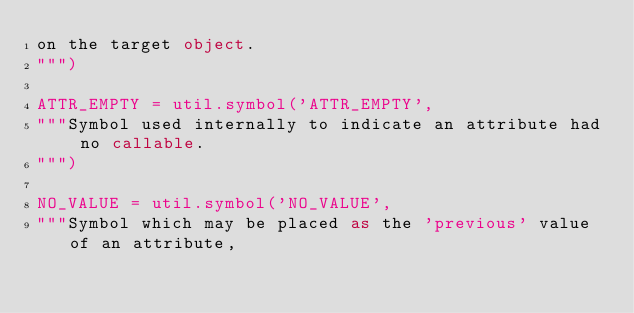<code> <loc_0><loc_0><loc_500><loc_500><_Python_>on the target object.
""")

ATTR_EMPTY = util.symbol('ATTR_EMPTY',
"""Symbol used internally to indicate an attribute had no callable.
""")

NO_VALUE = util.symbol('NO_VALUE',
"""Symbol which may be placed as the 'previous' value of an attribute,</code> 